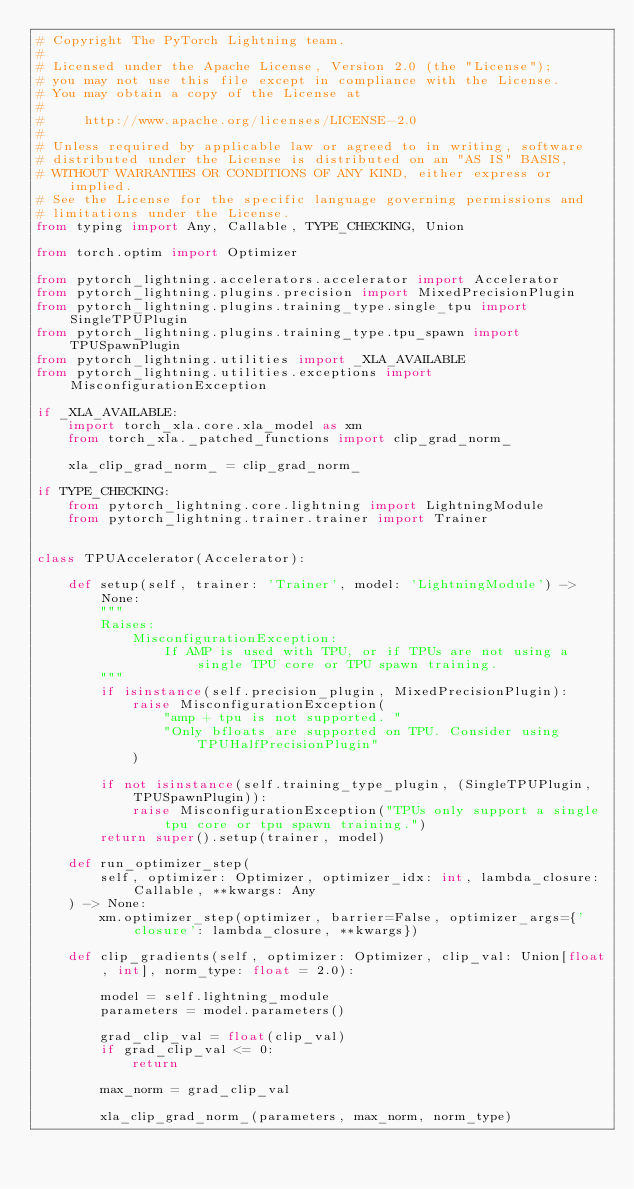Convert code to text. <code><loc_0><loc_0><loc_500><loc_500><_Python_># Copyright The PyTorch Lightning team.
#
# Licensed under the Apache License, Version 2.0 (the "License");
# you may not use this file except in compliance with the License.
# You may obtain a copy of the License at
#
#     http://www.apache.org/licenses/LICENSE-2.0
#
# Unless required by applicable law or agreed to in writing, software
# distributed under the License is distributed on an "AS IS" BASIS,
# WITHOUT WARRANTIES OR CONDITIONS OF ANY KIND, either express or implied.
# See the License for the specific language governing permissions and
# limitations under the License.
from typing import Any, Callable, TYPE_CHECKING, Union

from torch.optim import Optimizer

from pytorch_lightning.accelerators.accelerator import Accelerator
from pytorch_lightning.plugins.precision import MixedPrecisionPlugin
from pytorch_lightning.plugins.training_type.single_tpu import SingleTPUPlugin
from pytorch_lightning.plugins.training_type.tpu_spawn import TPUSpawnPlugin
from pytorch_lightning.utilities import _XLA_AVAILABLE
from pytorch_lightning.utilities.exceptions import MisconfigurationException

if _XLA_AVAILABLE:
    import torch_xla.core.xla_model as xm
    from torch_xla._patched_functions import clip_grad_norm_

    xla_clip_grad_norm_ = clip_grad_norm_

if TYPE_CHECKING:
    from pytorch_lightning.core.lightning import LightningModule
    from pytorch_lightning.trainer.trainer import Trainer


class TPUAccelerator(Accelerator):

    def setup(self, trainer: 'Trainer', model: 'LightningModule') -> None:
        """
        Raises:
            MisconfigurationException:
                If AMP is used with TPU, or if TPUs are not using a single TPU core or TPU spawn training.
        """
        if isinstance(self.precision_plugin, MixedPrecisionPlugin):
            raise MisconfigurationException(
                "amp + tpu is not supported. "
                "Only bfloats are supported on TPU. Consider using TPUHalfPrecisionPlugin"
            )

        if not isinstance(self.training_type_plugin, (SingleTPUPlugin, TPUSpawnPlugin)):
            raise MisconfigurationException("TPUs only support a single tpu core or tpu spawn training.")
        return super().setup(trainer, model)

    def run_optimizer_step(
        self, optimizer: Optimizer, optimizer_idx: int, lambda_closure: Callable, **kwargs: Any
    ) -> None:
        xm.optimizer_step(optimizer, barrier=False, optimizer_args={'closure': lambda_closure, **kwargs})

    def clip_gradients(self, optimizer: Optimizer, clip_val: Union[float, int], norm_type: float = 2.0):

        model = self.lightning_module
        parameters = model.parameters()

        grad_clip_val = float(clip_val)
        if grad_clip_val <= 0:
            return

        max_norm = grad_clip_val

        xla_clip_grad_norm_(parameters, max_norm, norm_type)
</code> 